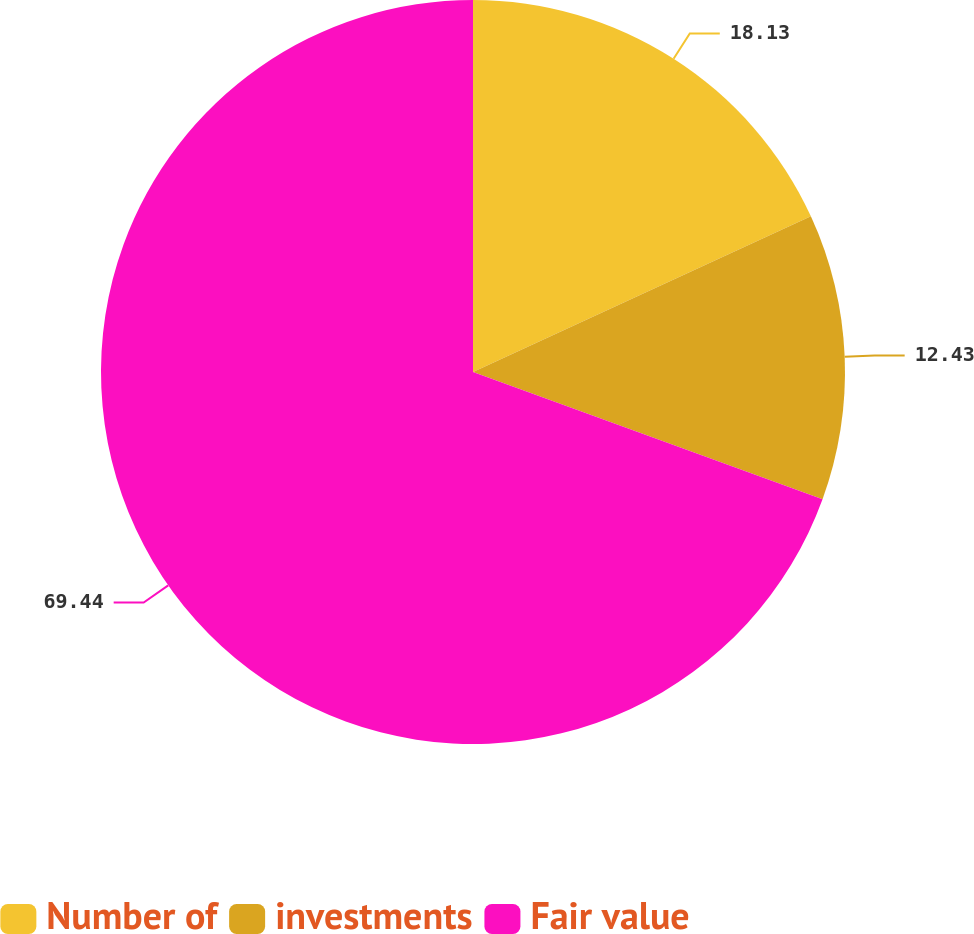Convert chart. <chart><loc_0><loc_0><loc_500><loc_500><pie_chart><fcel>Number of<fcel>investments<fcel>Fair value<nl><fcel>18.13%<fcel>12.43%<fcel>69.44%<nl></chart> 